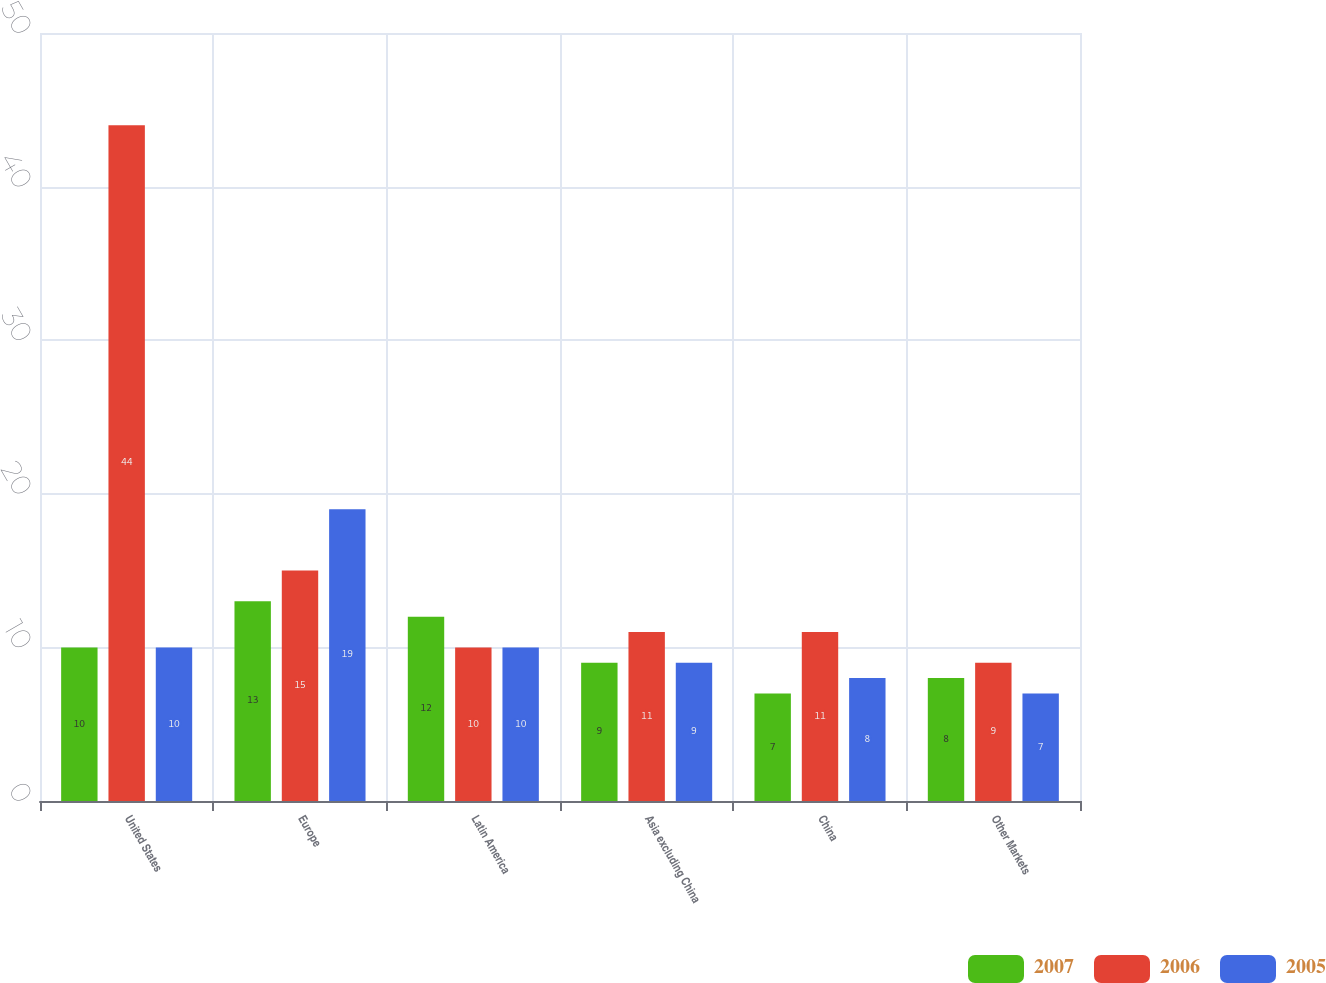<chart> <loc_0><loc_0><loc_500><loc_500><stacked_bar_chart><ecel><fcel>United States<fcel>Europe<fcel>Latin America<fcel>Asia excluding China<fcel>China<fcel>Other Markets<nl><fcel>2007<fcel>10<fcel>13<fcel>12<fcel>9<fcel>7<fcel>8<nl><fcel>2006<fcel>44<fcel>15<fcel>10<fcel>11<fcel>11<fcel>9<nl><fcel>2005<fcel>10<fcel>19<fcel>10<fcel>9<fcel>8<fcel>7<nl></chart> 